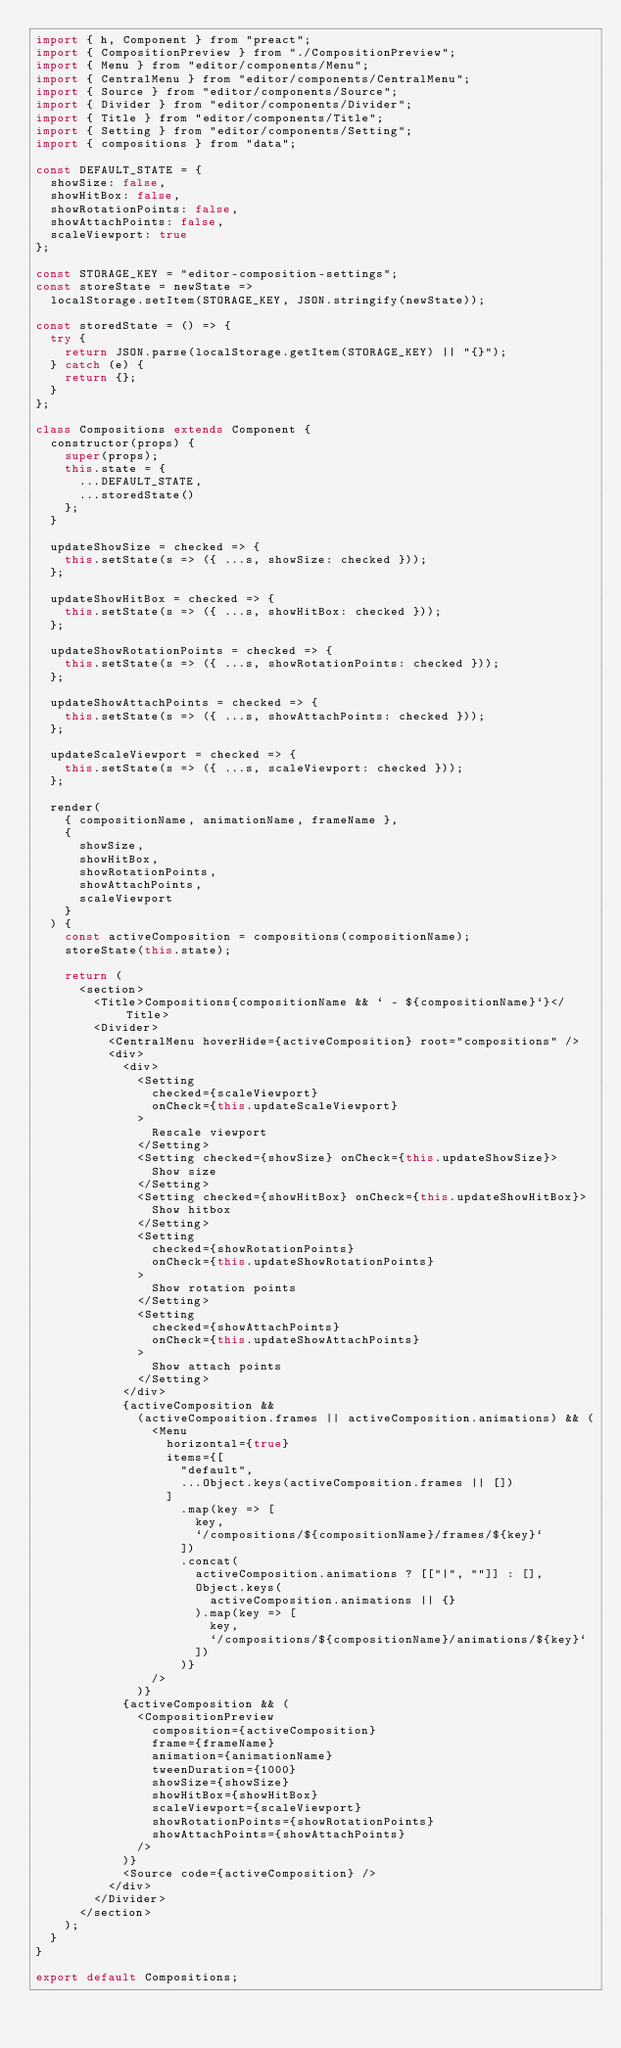Convert code to text. <code><loc_0><loc_0><loc_500><loc_500><_JavaScript_>import { h, Component } from "preact";
import { CompositionPreview } from "./CompositionPreview";
import { Menu } from "editor/components/Menu";
import { CentralMenu } from "editor/components/CentralMenu";
import { Source } from "editor/components/Source";
import { Divider } from "editor/components/Divider";
import { Title } from "editor/components/Title";
import { Setting } from "editor/components/Setting";
import { compositions } from "data";

const DEFAULT_STATE = {
  showSize: false,
  showHitBox: false,
  showRotationPoints: false,
  showAttachPoints: false,
  scaleViewport: true
};

const STORAGE_KEY = "editor-composition-settings";
const storeState = newState =>
  localStorage.setItem(STORAGE_KEY, JSON.stringify(newState));

const storedState = () => {
  try {
    return JSON.parse(localStorage.getItem(STORAGE_KEY) || "{}");
  } catch (e) {
    return {};
  }
};

class Compositions extends Component {
  constructor(props) {
    super(props);
    this.state = {
      ...DEFAULT_STATE,
      ...storedState()
    };
  }

  updateShowSize = checked => {
    this.setState(s => ({ ...s, showSize: checked }));
  };

  updateShowHitBox = checked => {
    this.setState(s => ({ ...s, showHitBox: checked }));
  };

  updateShowRotationPoints = checked => {
    this.setState(s => ({ ...s, showRotationPoints: checked }));
  };

  updateShowAttachPoints = checked => {
    this.setState(s => ({ ...s, showAttachPoints: checked }));
  };

  updateScaleViewport = checked => {
    this.setState(s => ({ ...s, scaleViewport: checked }));
  };

  render(
    { compositionName, animationName, frameName },
    {
      showSize,
      showHitBox,
      showRotationPoints,
      showAttachPoints,
      scaleViewport
    }
  ) {
    const activeComposition = compositions(compositionName);
    storeState(this.state);

    return (
      <section>
        <Title>Compositions{compositionName && ` - ${compositionName}`}</Title>
        <Divider>
          <CentralMenu hoverHide={activeComposition} root="compositions" />
          <div>
            <div>
              <Setting
                checked={scaleViewport}
                onCheck={this.updateScaleViewport}
              >
                Rescale viewport
              </Setting>
              <Setting checked={showSize} onCheck={this.updateShowSize}>
                Show size
              </Setting>
              <Setting checked={showHitBox} onCheck={this.updateShowHitBox}>
                Show hitbox
              </Setting>
              <Setting
                checked={showRotationPoints}
                onCheck={this.updateShowRotationPoints}
              >
                Show rotation points
              </Setting>
              <Setting
                checked={showAttachPoints}
                onCheck={this.updateShowAttachPoints}
              >
                Show attach points
              </Setting>
            </div>
            {activeComposition &&
              (activeComposition.frames || activeComposition.animations) && (
                <Menu
                  horizontal={true}
                  items={[
                    "default",
                    ...Object.keys(activeComposition.frames || [])
                  ]
                    .map(key => [
                      key,
                      `/compositions/${compositionName}/frames/${key}`
                    ])
                    .concat(
                      activeComposition.animations ? [["|", ""]] : [],
                      Object.keys(
                        activeComposition.animations || {}
                      ).map(key => [
                        key,
                        `/compositions/${compositionName}/animations/${key}`
                      ])
                    )}
                />
              )}
            {activeComposition && (
              <CompositionPreview
                composition={activeComposition}
                frame={frameName}
                animation={animationName}
                tweenDuration={1000}
                showSize={showSize}
                showHitBox={showHitBox}
                scaleViewport={scaleViewport}
                showRotationPoints={showRotationPoints}
                showAttachPoints={showAttachPoints}
              />
            )}
            <Source code={activeComposition} />
          </div>
        </Divider>
      </section>
    );
  }
}

export default Compositions;
</code> 